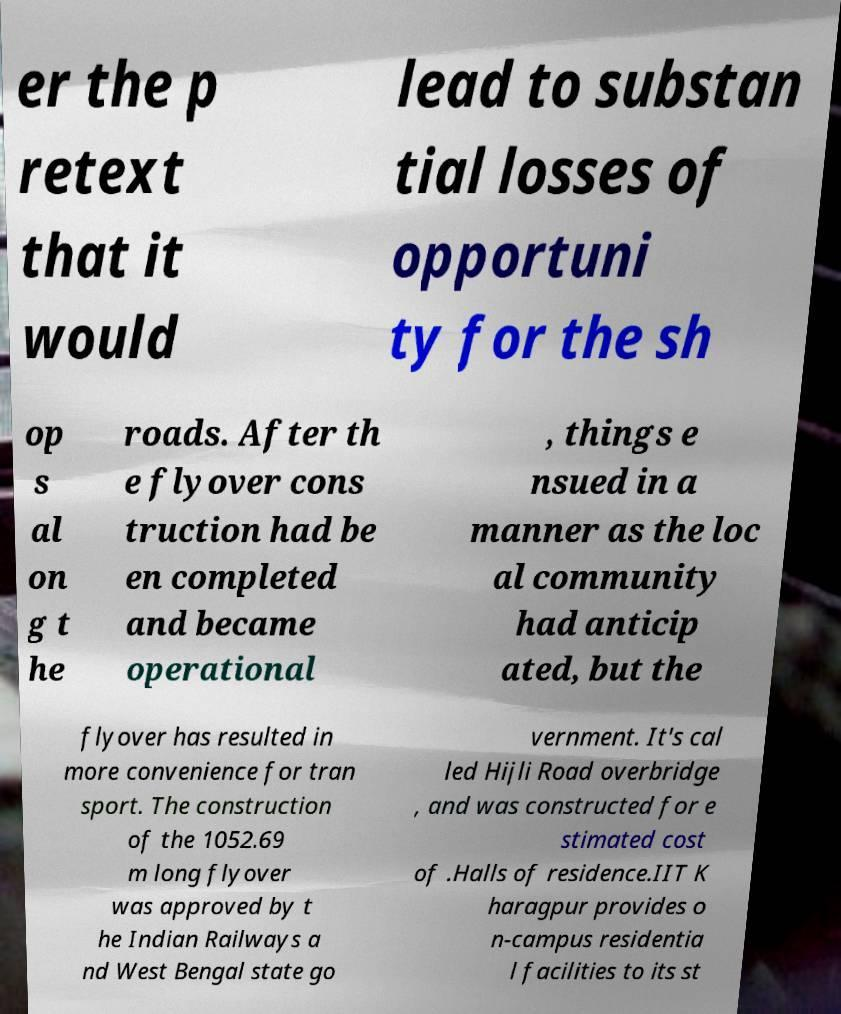Please read and relay the text visible in this image. What does it say? er the p retext that it would lead to substan tial losses of opportuni ty for the sh op s al on g t he roads. After th e flyover cons truction had be en completed and became operational , things e nsued in a manner as the loc al community had anticip ated, but the flyover has resulted in more convenience for tran sport. The construction of the 1052.69 m long flyover was approved by t he Indian Railways a nd West Bengal state go vernment. It's cal led Hijli Road overbridge , and was constructed for e stimated cost of .Halls of residence.IIT K haragpur provides o n-campus residentia l facilities to its st 